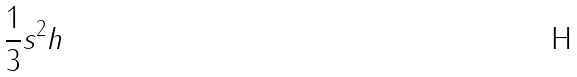<formula> <loc_0><loc_0><loc_500><loc_500>\frac { 1 } { 3 } s ^ { 2 } h</formula> 